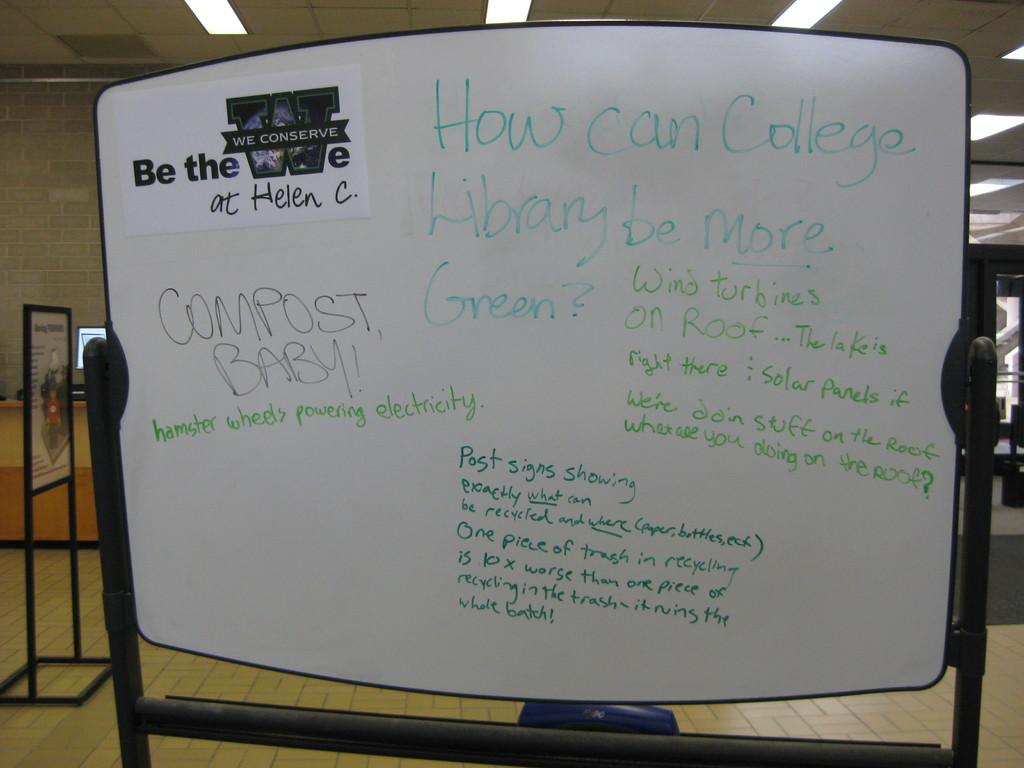<image>
Give a short and clear explanation of the subsequent image. White board that says COMPOST BABY in black letters. 